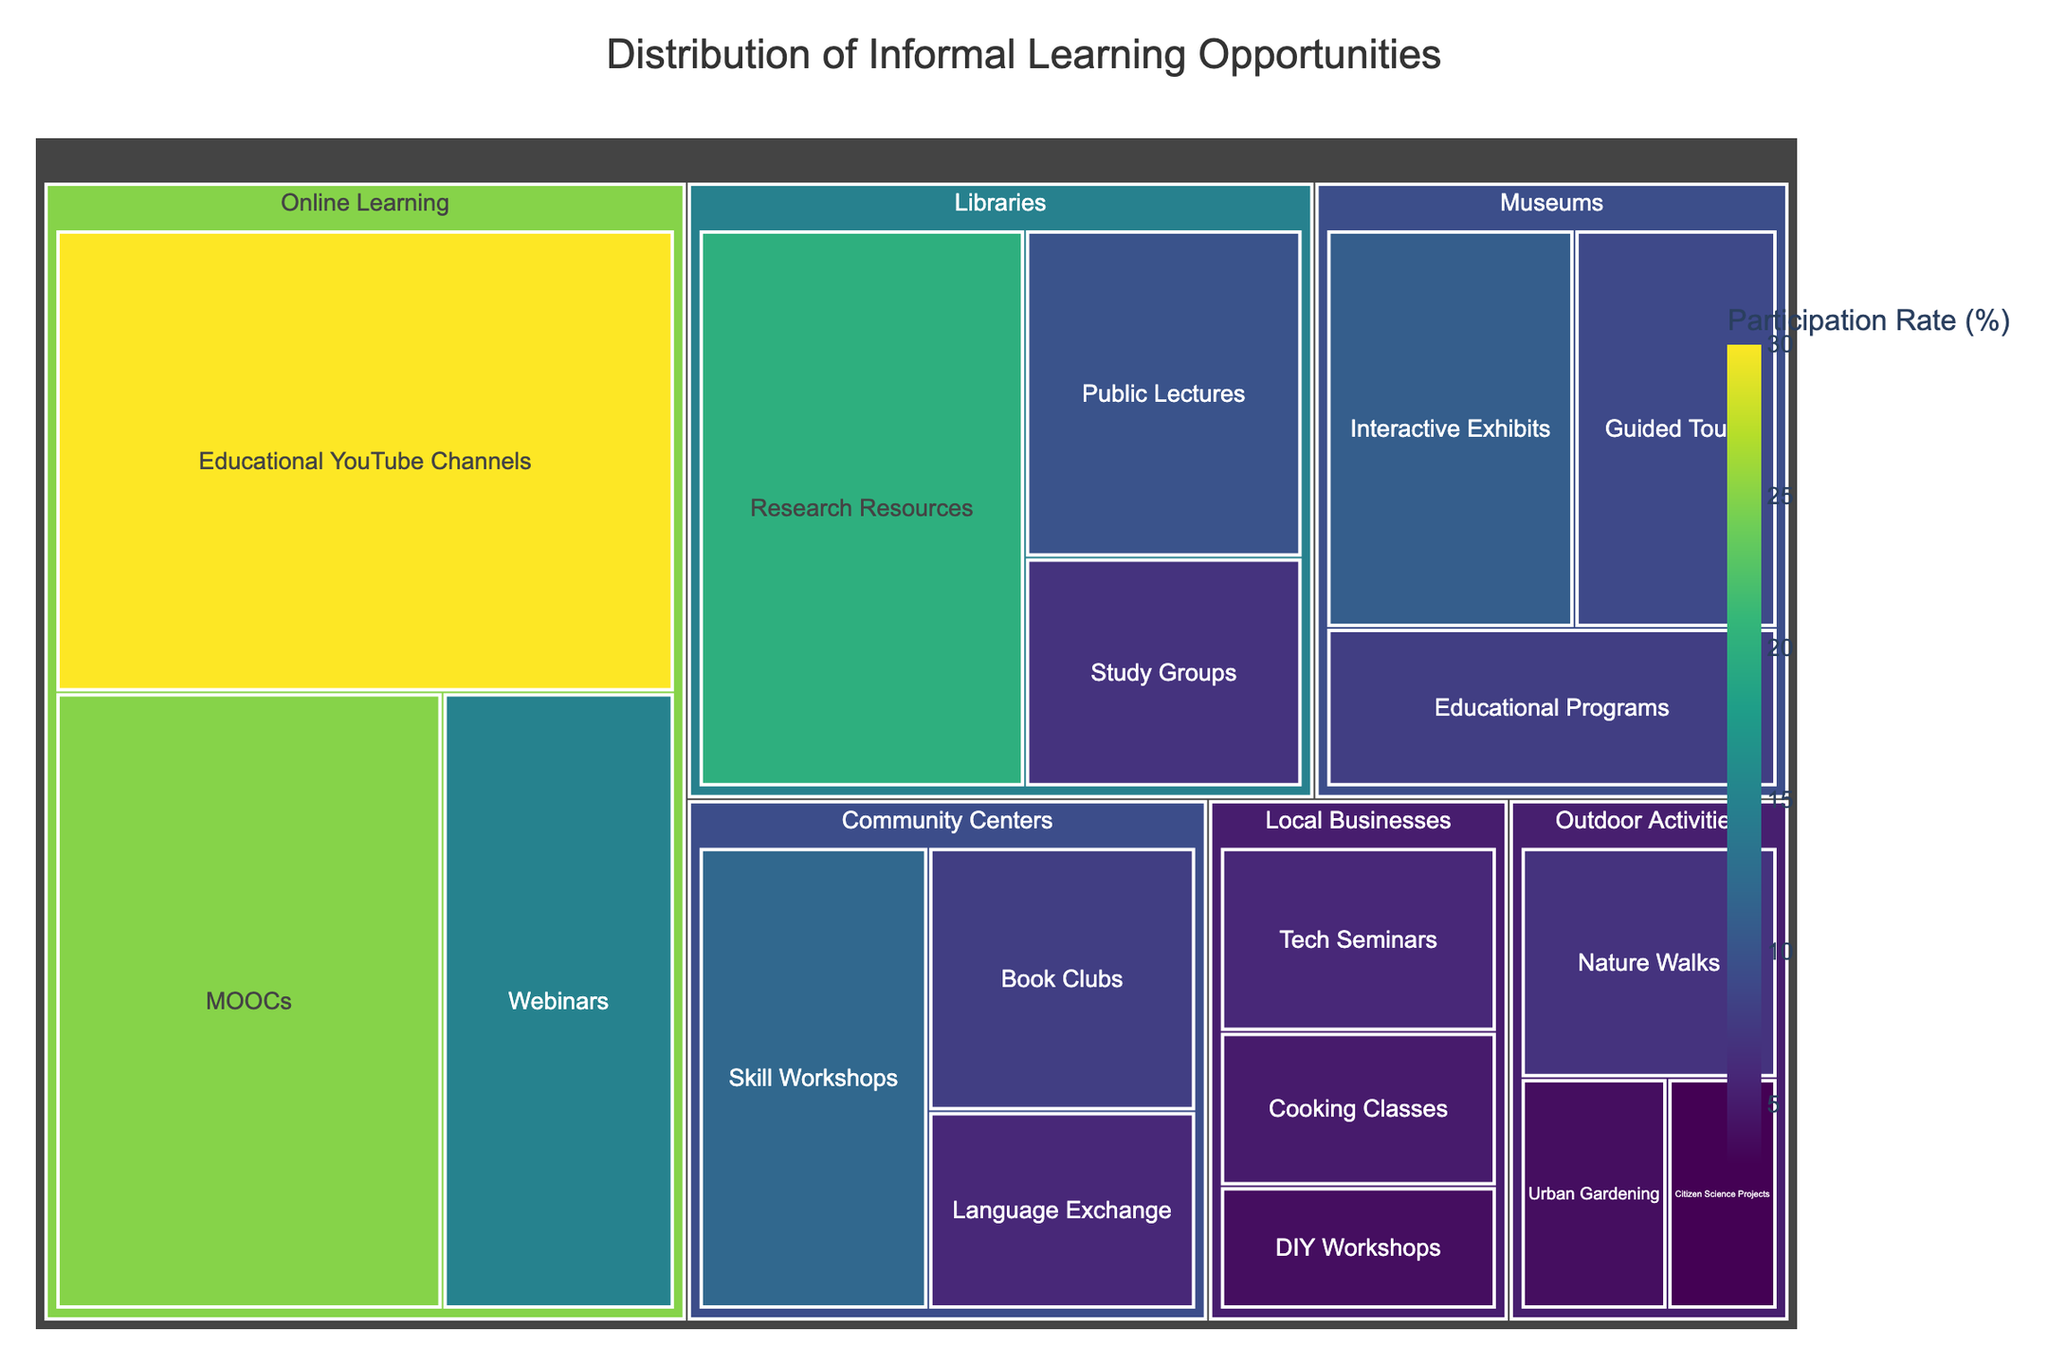What category has the highest overall participation rate? To determine the category with the highest participation rate, look for the category with the largest combined values. Online Learning has the largest combined participation rate when you add MOOCs (25), Educational YouTube Channels (30), and Webinars (15), making a total of 70.
Answer: Online Learning Which subcategory within Online Learning has the highest participation rate? Observe the subcategories under Online Learning and their values. Educational YouTube Channels has the highest participation rate at 30%.
Answer: Educational YouTube Channels What is the participation rate for Skill Workshops in Community Centers? Identify the participation rates listed under Community Centers and locate Skill Workshops. The participation rate is 12%.
Answer: 12% How does the participation rate of Webinars compare to that of Public Lectures in Libraries? Locate the participation rates for Webinars within Online Learning and Public Lectures in Libraries. Webinars have a rate of 15%, while Public Lectures have a rate of 10%. 15% is greater than 10%.
Answer: Webinars have a higher participation rate What is the total participation rate for all the subcategories within Libraries? Add the participation rates for Public Lectures (10), Research Resources (20), and Study Groups (7). The total is 10 + 20 + 7 = 37.
Answer: 37% Which subcategory within Museums has the lowest participation rate? Look at the subcategories within Museums. Guided Tours (9), Interactive Exhibits (11), and Educational Programs (8). The lowest is Educational Programs with 8%.
Answer: Educational Programs How many subcategories have a participation rate greater than 10%? Count subcategories where the Participation Rate is above 10%. These are MOOCs (25), Educational YouTube Channels (30), Webinars (15), Research Resources (20), Skill Workshops (12), and Interactive Exhibits (11), summing up to 6 subcategories.
Answer: 6 subcategories What is the average participation rate for all subcategories within Outdoor Activities? Calculate the average by adding the participation rates for Nature Walks (7), Citizen Science Projects (3), and Urban Gardening (4), then divide by the number of subcategories: (7 + 3 + 4) / 3 = 14 / 3 ≈ 4.67%.
Answer: 4.67% Which has a higher participation rate: DIY Workshops in Local Businesses or Book Clubs in Community Centers? Compare the participation rates of DIY Workshops (4%) and Book Clubs (8%). Book Clubs have a higher rate.
Answer: Book Clubs What color scheme is used to represent the participation rates? The color scheme used is Viridis, a gradient that typically ranges from purple to yellow, representing participation rates.
Answer: Viridis 